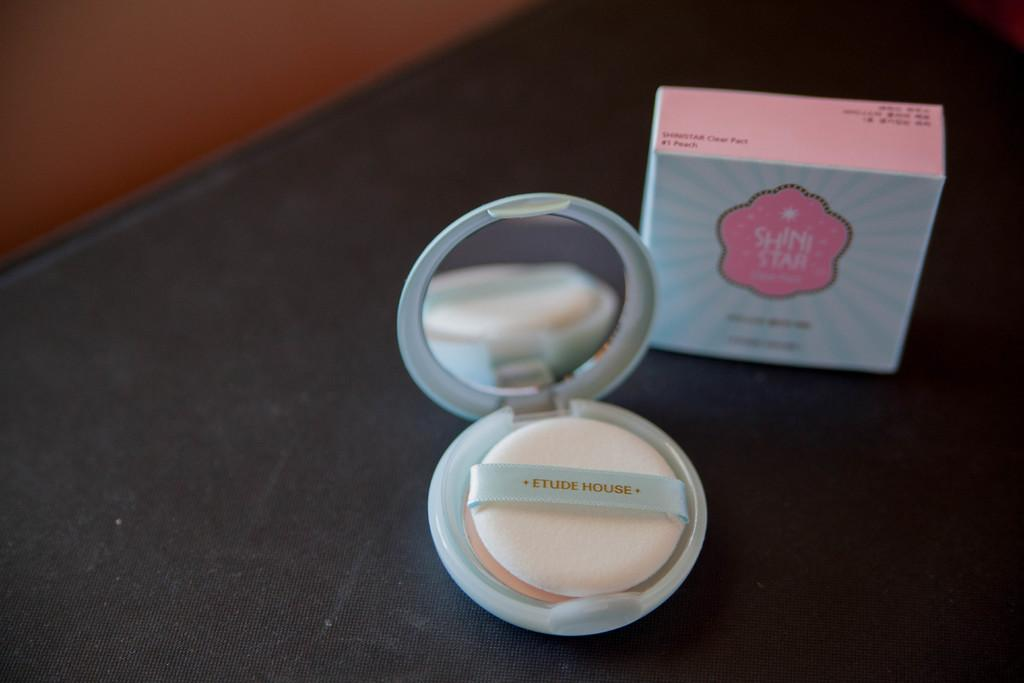What object is present in the image? There is a box in the image. What is inside the box? There is a compact powder in the image. What is the color of the platform on which the box and compact powder are placed? The platform is black in color. Can you see any butter melting on the compact powder in the image? There is no butter present in the image, so it cannot be melting on the compact powder. 